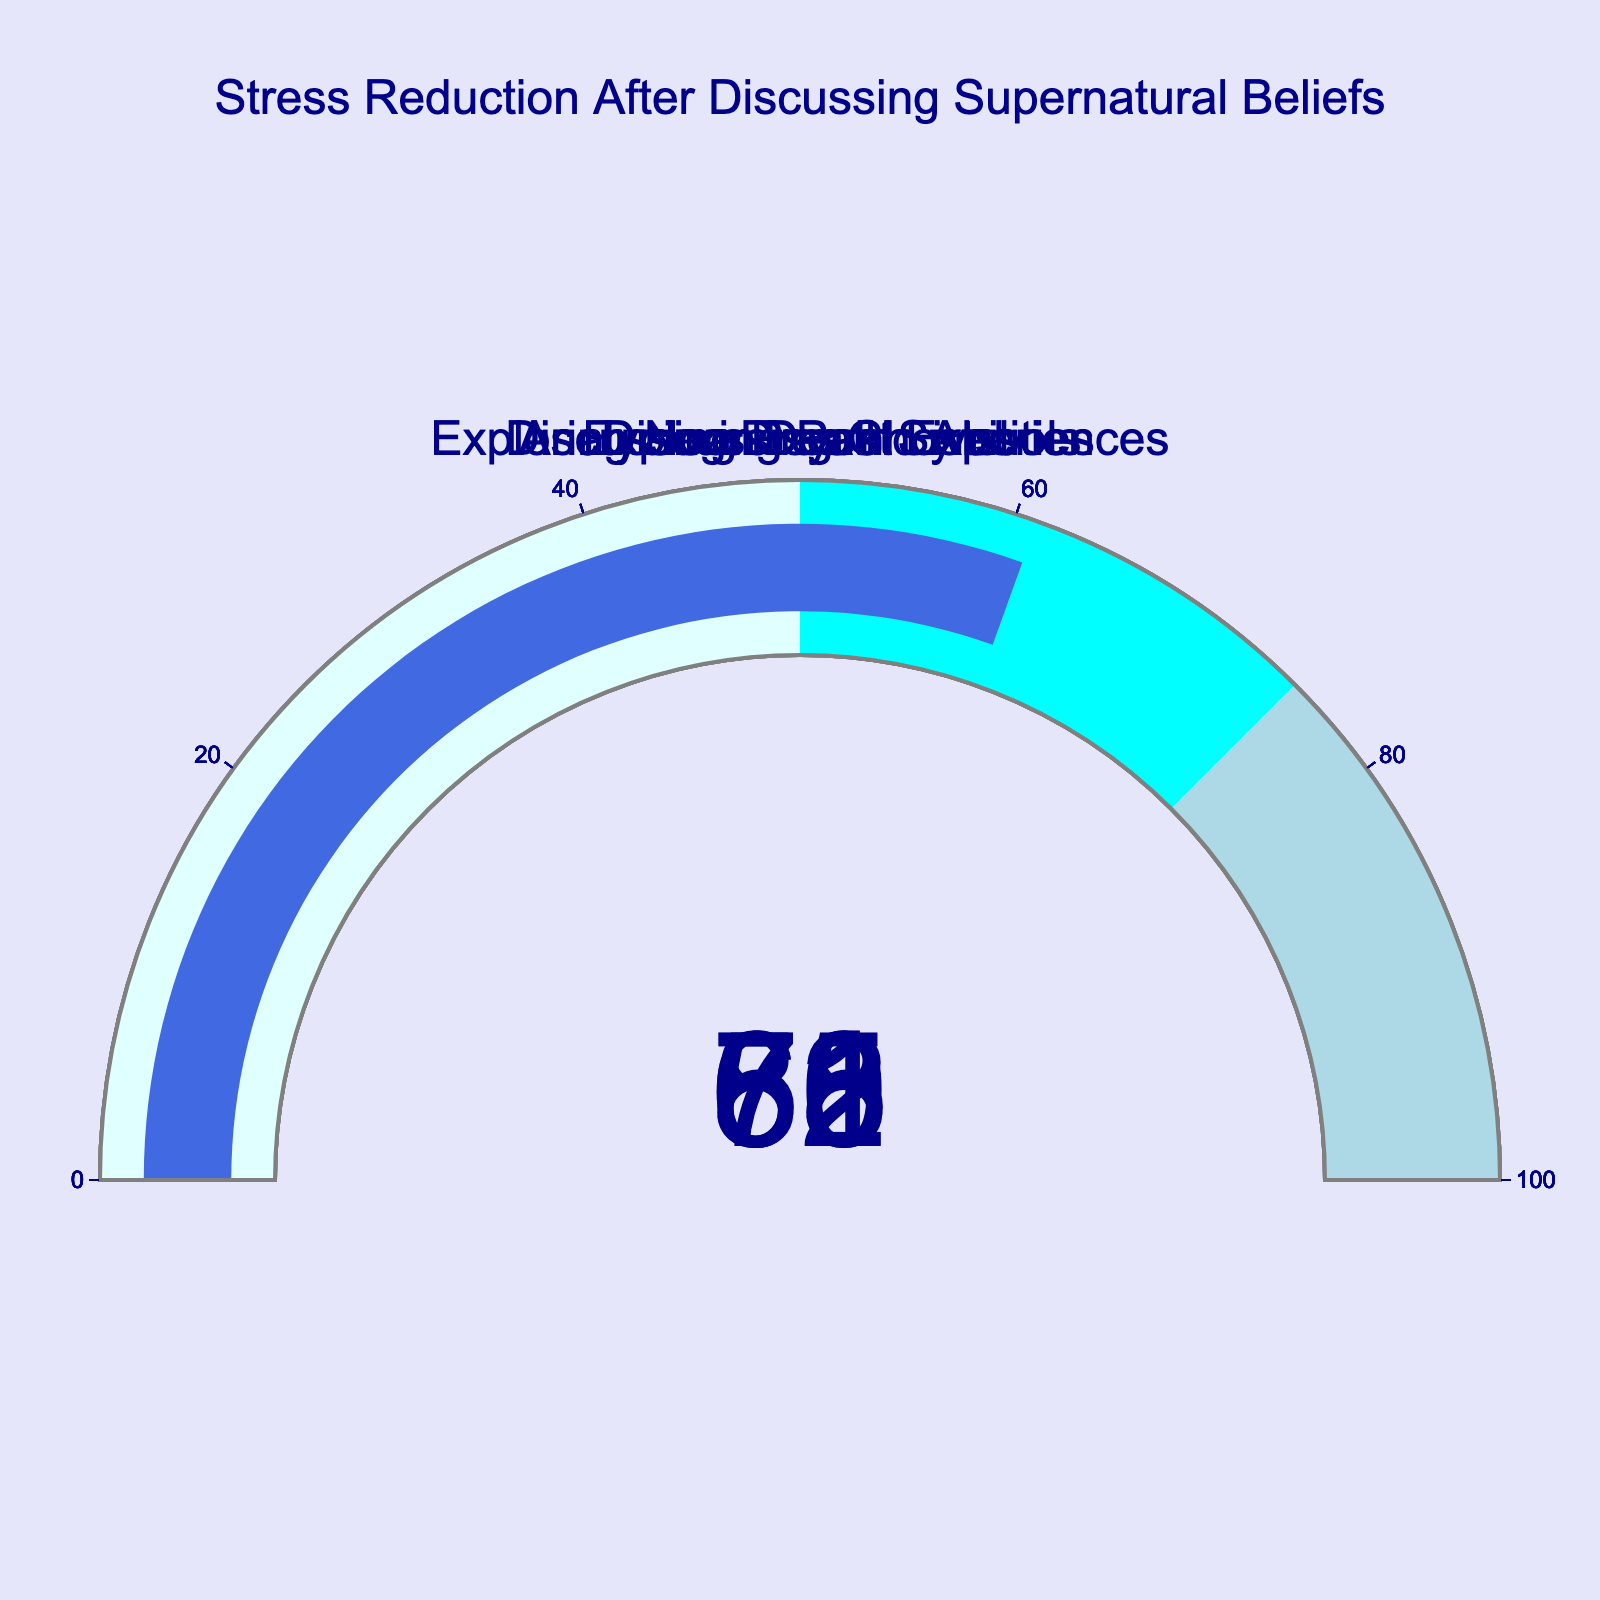What's the highest stress reduction category? All the gauge values need to be checked and compared. "Exploring Near-Death Experiences" has the highest stress reduction value of 80.
Answer: "Exploring Near-Death Experiences" with 80 How many categories have a stress reduction value above 60? Count the number of gauge values that are above 60. These values are 65, 72, 80, and 61, which makes 4 categories.
Answer: 4 What is the average stress reduction value for all categories? First, sum all the stress reduction values: 65 + 72 + 58 + 80 + 61 = 336. Then, divide this by the number of categories, which is 5. 336 / 5 = 67.2
Answer: 67.2 Which category has the lowest stress reduction value? Compare all the gauge values. "Analyzing Dream Symbols" has the lowest value at 58.
Answer: "Analyzing Dream Symbols" with 58 Is the stress reduction for "Discussing Ghosts" higher than the average? The average value is 67.2. "Discussing Ghosts" has a value of 65, which is lower than 67.2.
Answer: No What is the median stress reduction value across all categories? Arrange the values in ascending order: 58, 61, 65, 72, 80. The median value is the middle one in this sorted list, which is 65.
Answer: 65 What's the difference in stress reduction between "Exploring Past Lives" and "Discussing Psychic Abilities"? Subtract the value for "Discussing Psychic Abilities" (61) from "Exploring Past Lives" (72). 72 - 61 = 11
Answer: 11 How much higher is the stress reduction for "Exploring Near-Death Experiences" compared to "Analyzing Dream Symbols"? Subtract the value of "Analyzing Dream Symbols" (58) from "Exploring Near-Death Experiences" (80). 80 - 58 = 22
Answer: 22 Which categories have stress reduction values between 60 and 70? Identify the gauge values within the range of 60 to 70. The categories are "Discussing Ghosts" (65) and "Discussing Psychic Abilities" (61).
Answer: "Discussing Ghosts" and "Discussing Psychic Abilities" Is the median value of stress reduction higher or lower than the average? The median value is 65, and the average is 67.2. Compare these two values; 65 is lower than 67.2.
Answer: Lower 